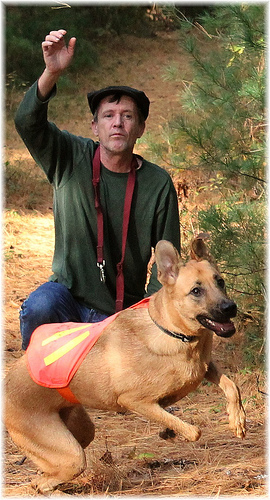<image>
Can you confirm if the dog is under the man? No. The dog is not positioned under the man. The vertical relationship between these objects is different. 